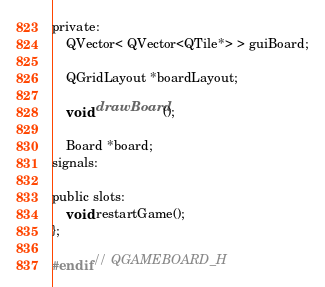<code> <loc_0><loc_0><loc_500><loc_500><_C_>private:
    QVector< QVector<QTile*> > guiBoard;

    QGridLayout *boardLayout;

    void drawBoard();

    Board *board;
signals:

public slots:
    void restartGame();
};

#endif // QGAMEBOARD_H
</code> 